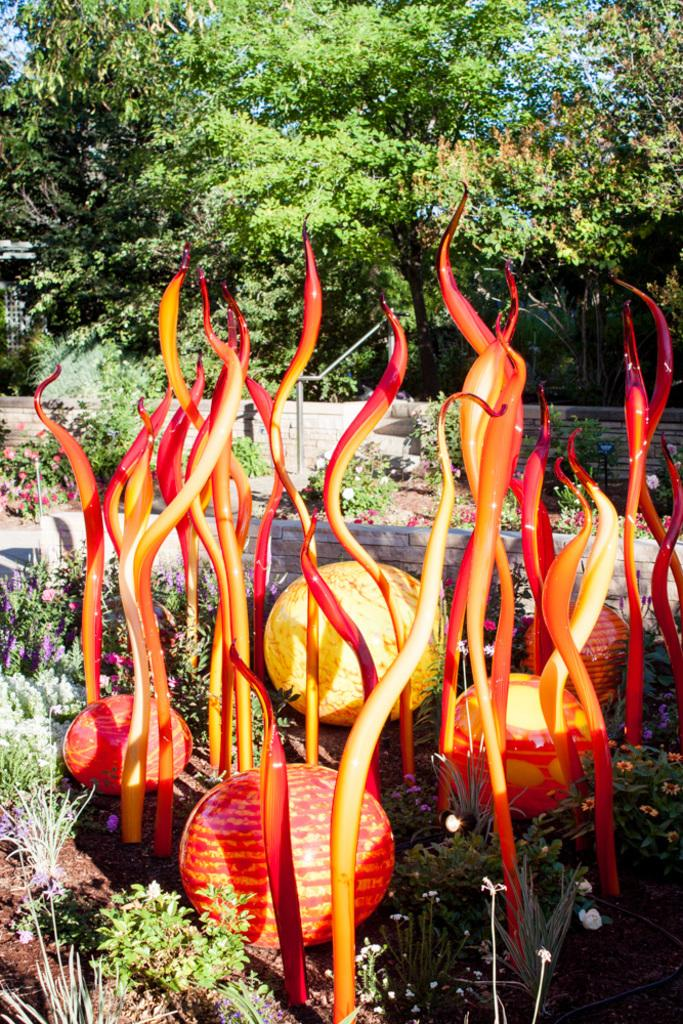What types of objects can be seen in the foreground of the image? There are fruits and other objects in the foreground of the image. What types of plants are present in the image? There are plants and flowers in the image. What type of terrain is visible in the image? There is sand in the image. What can be seen in the background of the image? There is a wall and trees in the background of the image. Can you see a horse in the image? There is no horse present in the image. 